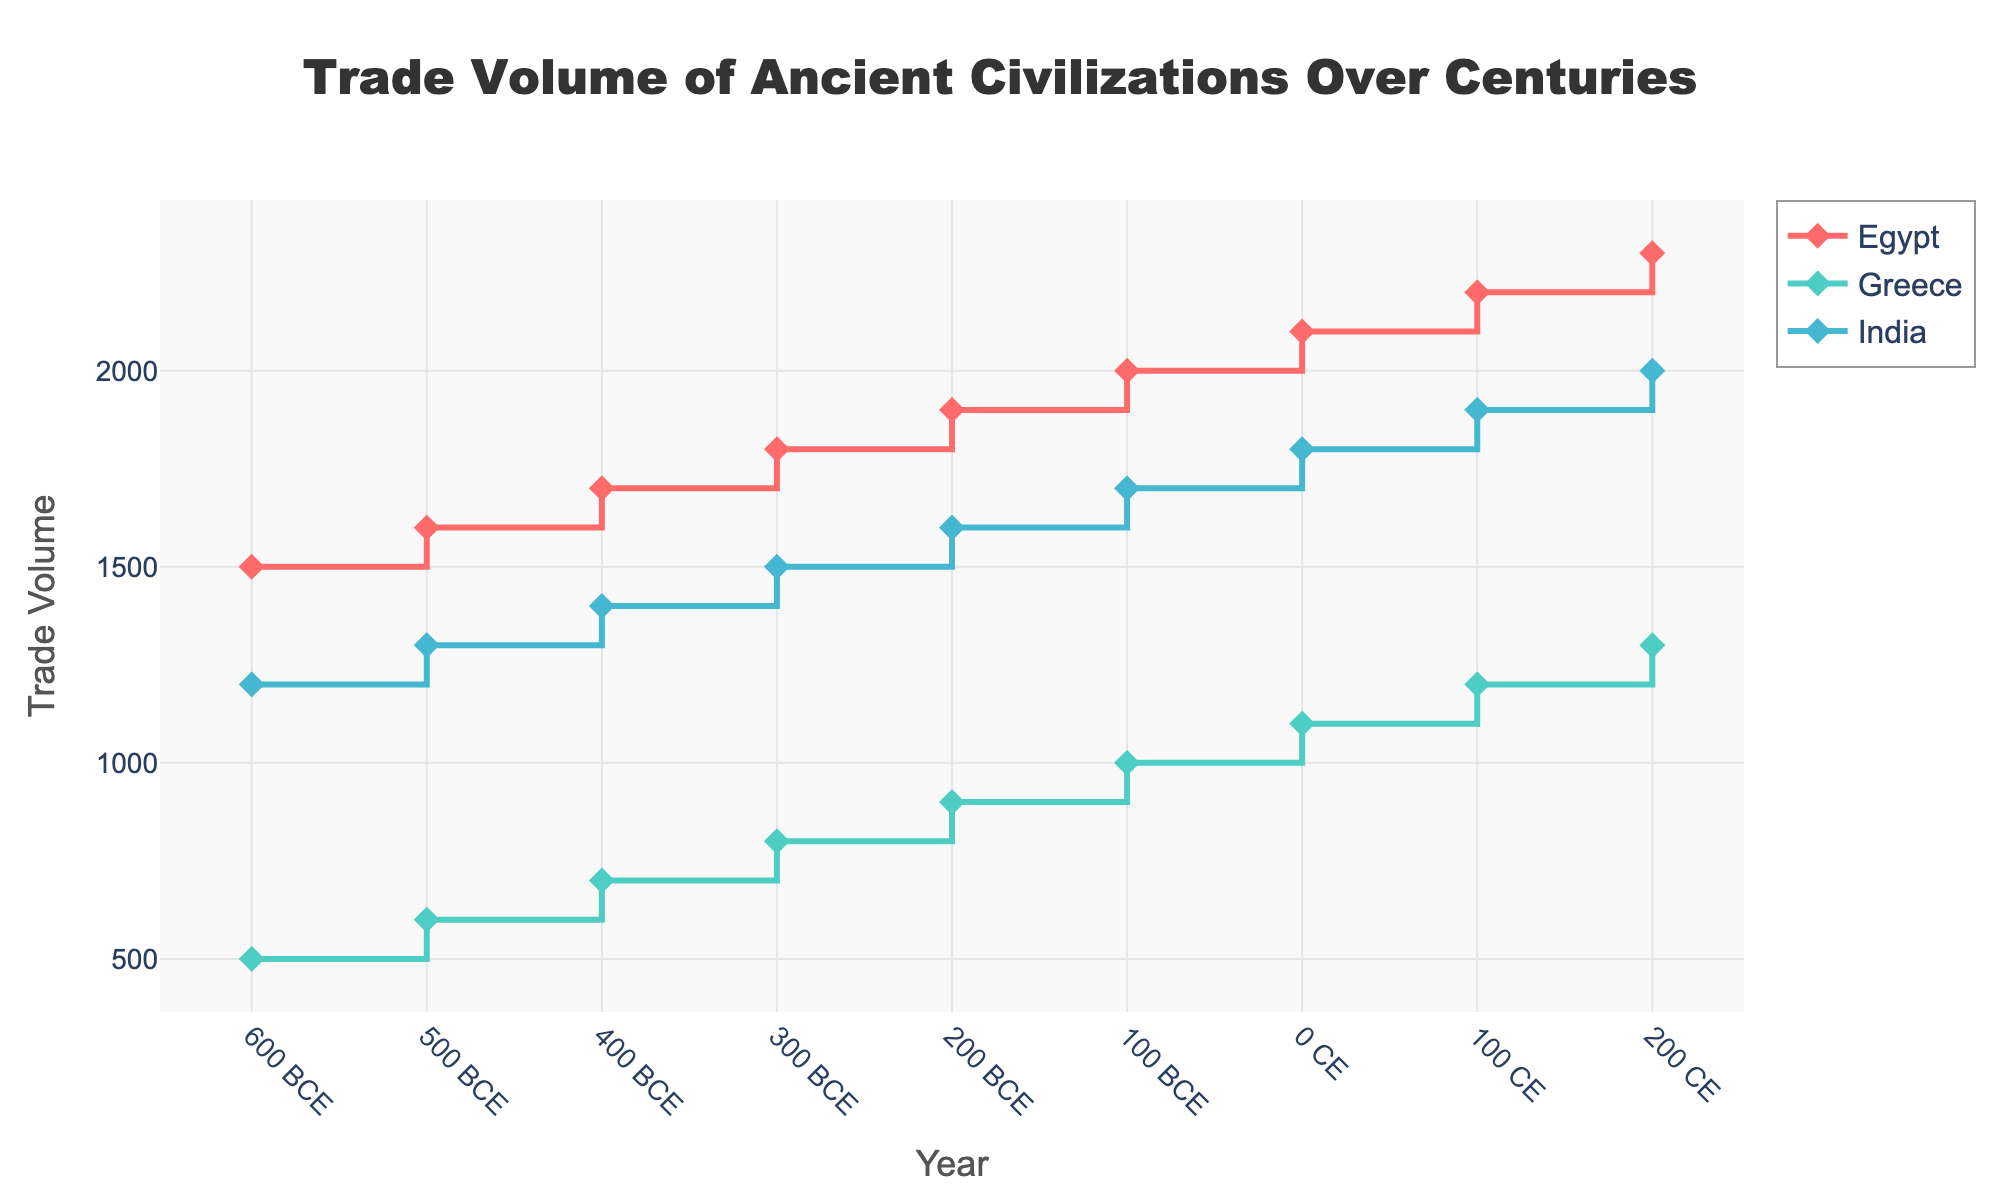What is the title of the figure? The title of the figure is usually located at the top and it provides an overview of what the figure is about. Upon inspecting, the title reads 'Trade Volume of Ancient Civilizations Over Centuries'.
Answer: Trade Volume of Ancient Civilizations Over Centuries Which civilization had the highest trade volume in 0 CE? By looking at the data points marked on the stair plot for the year 0 CE, we compare the trade volumes of Egypt, Greece, and India. Egypt has the highest trade volume of 2100 units at that time.
Answer: Egypt What is the trade volume of Greece in 100 CE? The data point for Greece in the year 100 CE can be located on the stair plot. The corresponding trade volume value is 1200 units.
Answer: 1200 How did the trade volume of Egypt change from 600 BCE to 100 CE? To determine this, we look at the trade volumes in the years 600 BCE (1500) and 100 CE (2200). The change is calculated as 2200 - 1500 = 700 units.
Answer: Increased by 700 Compare the trade volumes of Greece and India in 200 BCE. Which had a higher value and by how much? In 200 BCE, the trade volume for Greece is 900 and for India is 1600. India's trade volume is higher, and the difference is 1600 - 900 = 700 units.
Answer: India by 700 What trend can be observed in the trade volume of Egypt over the plotted time period? Observing the plot, the trade volume for Egypt shows a continuous increase over time with each data point depicting a growth except for the time intervals which stay constant due to the stair-step nature.
Answer: Continuous increase At what period did India surpass Greece in trade volume, and by how much at that point? India surpassed Greece already by 600 BCE, having a trade volume of 1200 compared to Greece's 500. The difference then is 1200 - 500 = 700 units.
Answer: By 600 BCE, by 700 units What is the highest trade volume recorded across all civilizations and times, and which civilization does it belong to? By scanning the stair plot for the highest y-value, we find that Egypt in 200 CE had the highest trade volume of 2300 units.
Answer: 2300, Egypt Calculate the average trade volume of Greece over the recorded periods. The trade volumes of Greece over the periods 600 BCE, 500 BCE, 400 BCE, 300 BCE, 200 BCE, 100 BCE, 0 CE, 100 CE, and 200 CE are 500, 600, 700, 800, 900, 1000, 1100, 1200, and 1300 respectively. The sum is 500 + 600 + 700 + 800 + 900 + 1000 + 1100 + 1200 + 1300 = 8100. Divided by 9, we get an average of 8100 / 9 = 900 units.
Answer: 900 